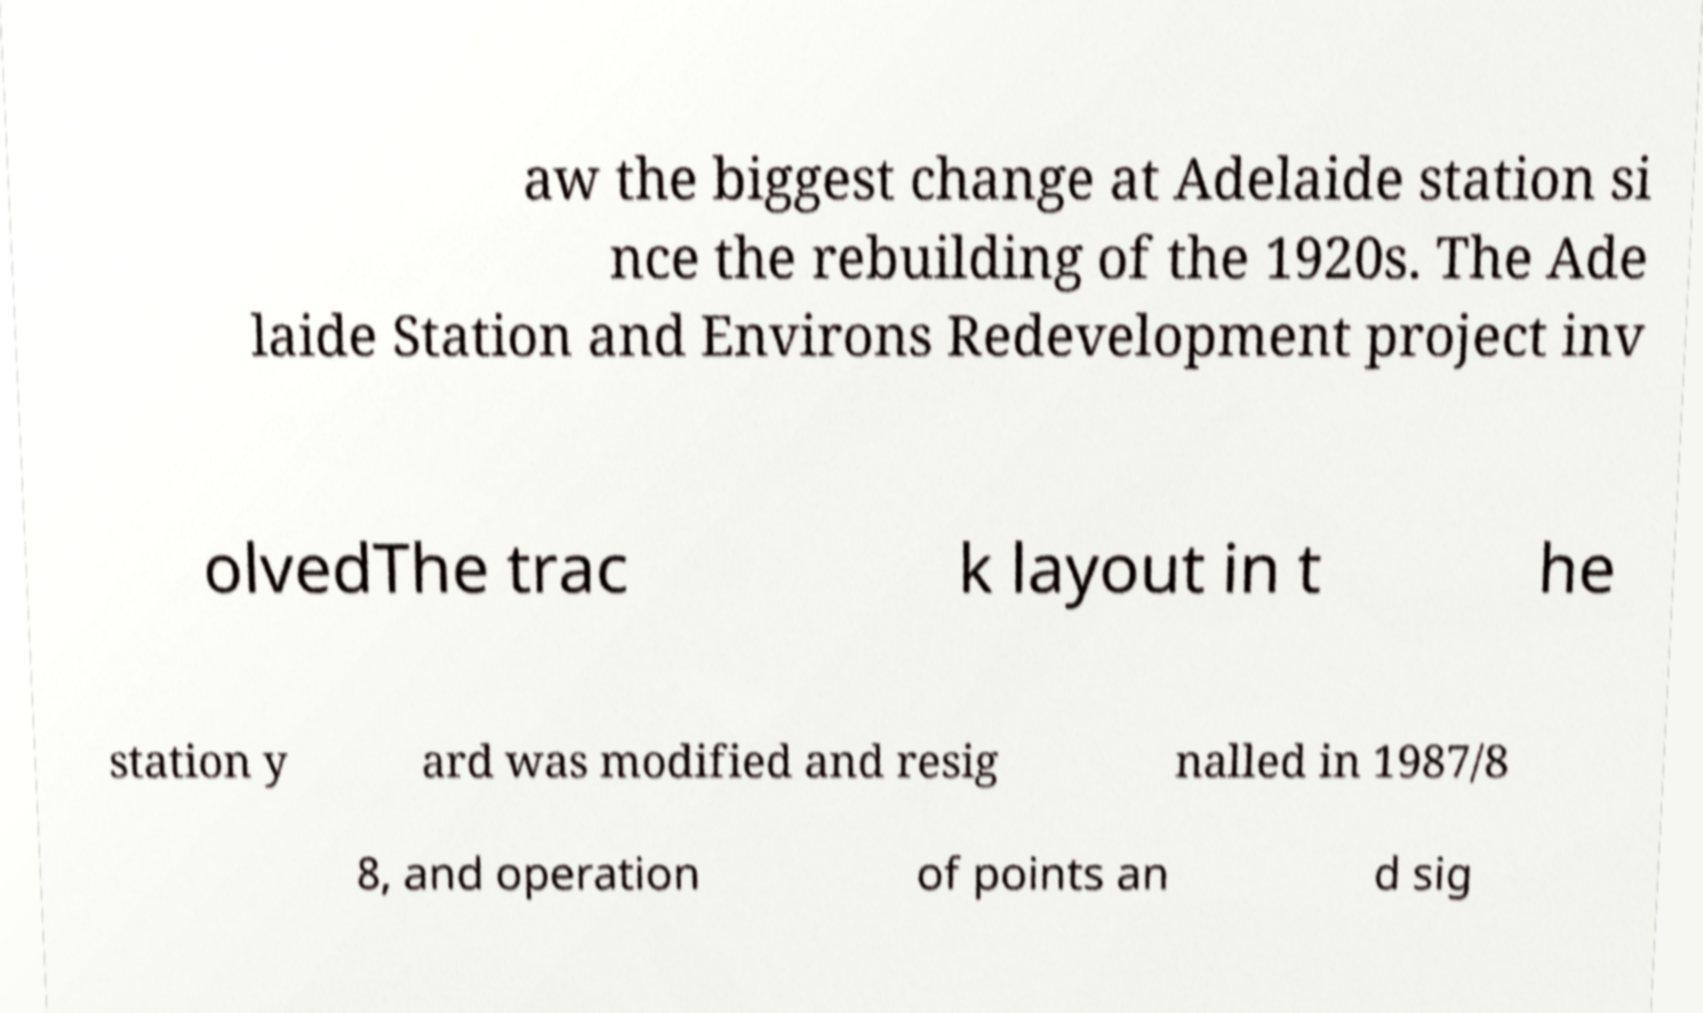There's text embedded in this image that I need extracted. Can you transcribe it verbatim? aw the biggest change at Adelaide station si nce the rebuilding of the 1920s. The Ade laide Station and Environs Redevelopment project inv olvedThe trac k layout in t he station y ard was modified and resig nalled in 1987/8 8, and operation of points an d sig 